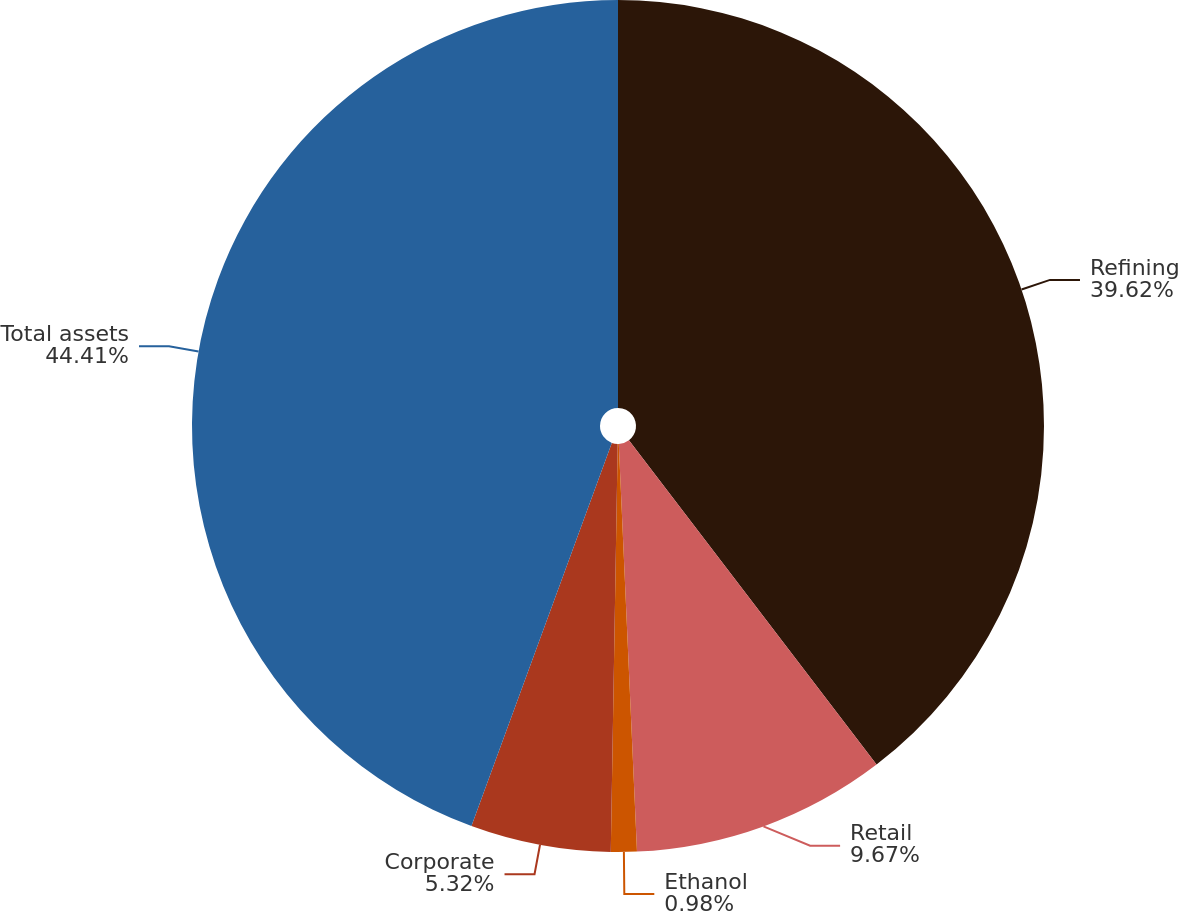Convert chart. <chart><loc_0><loc_0><loc_500><loc_500><pie_chart><fcel>Refining<fcel>Retail<fcel>Ethanol<fcel>Corporate<fcel>Total assets<nl><fcel>39.62%<fcel>9.67%<fcel>0.98%<fcel>5.32%<fcel>44.41%<nl></chart> 